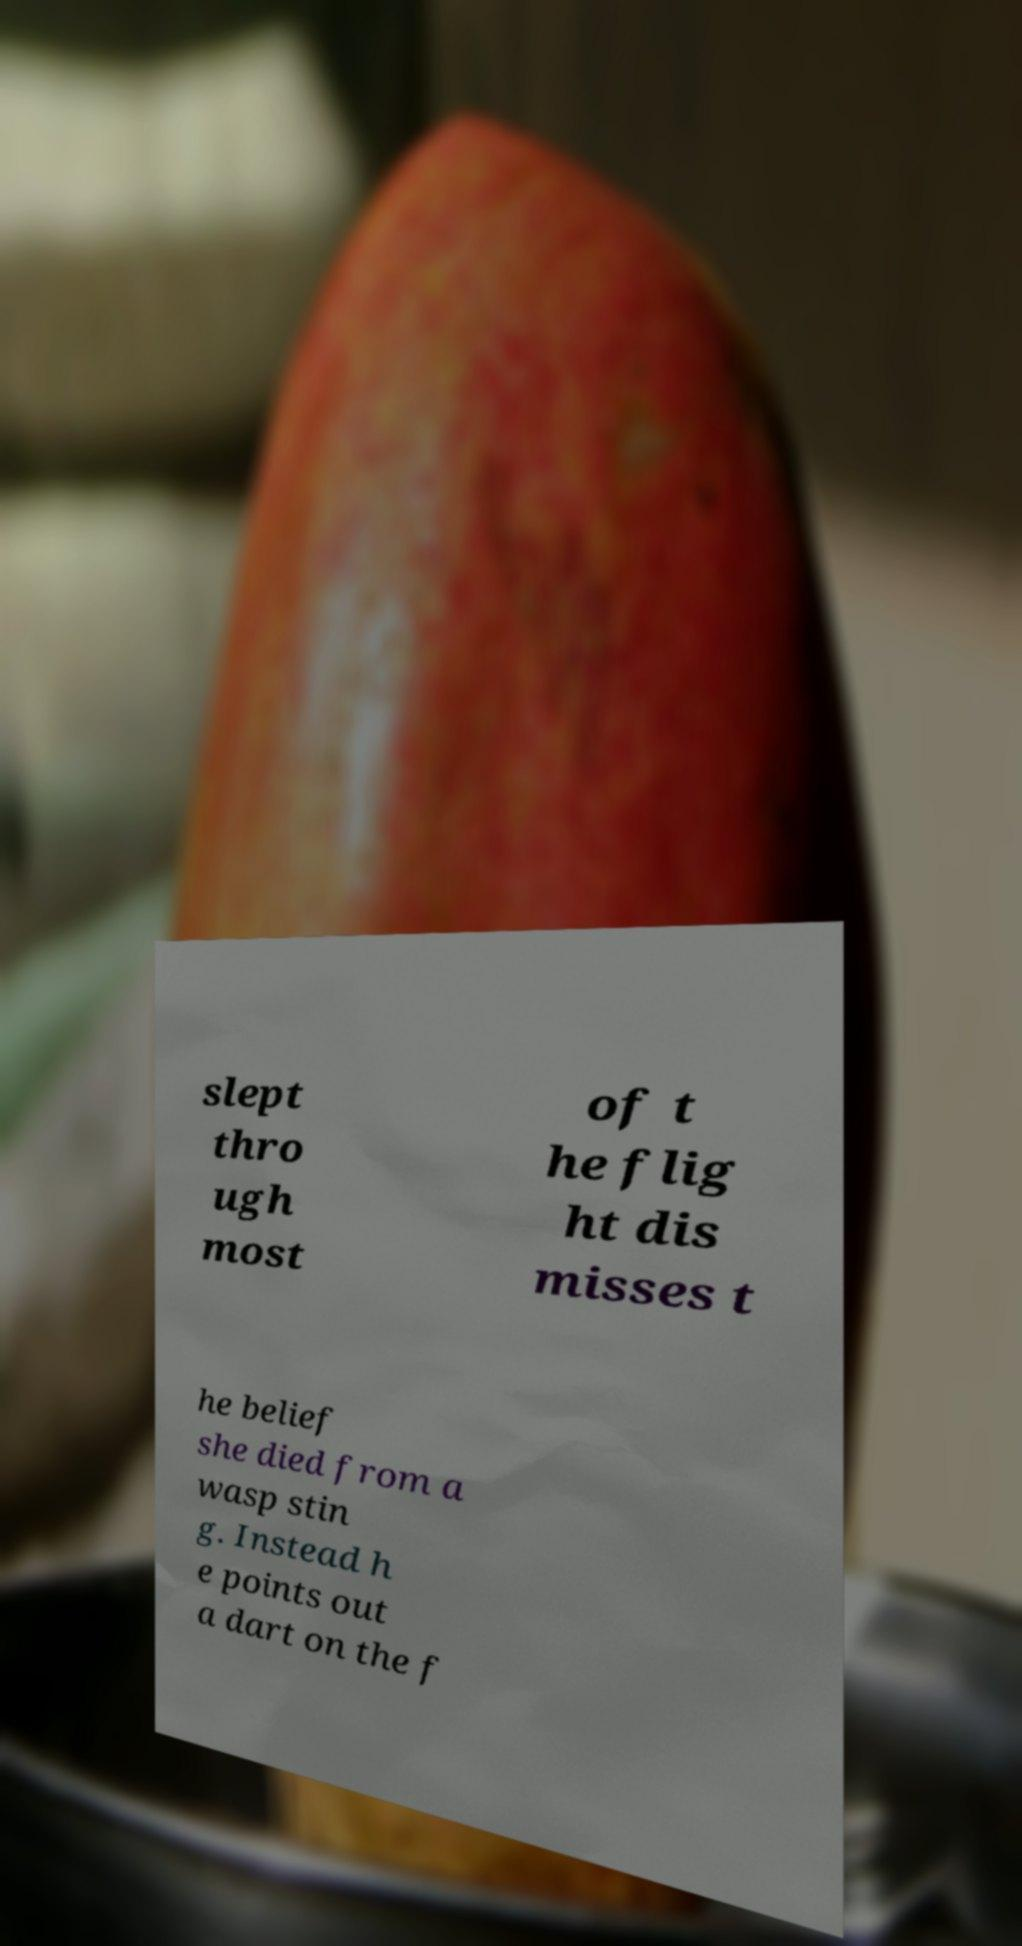Can you accurately transcribe the text from the provided image for me? slept thro ugh most of t he flig ht dis misses t he belief she died from a wasp stin g. Instead h e points out a dart on the f 